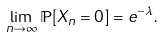<formula> <loc_0><loc_0><loc_500><loc_500>\lim _ { n \rightarrow \infty } \mathbb { P } [ X _ { n } = 0 ] = e ^ { - \lambda } .</formula> 